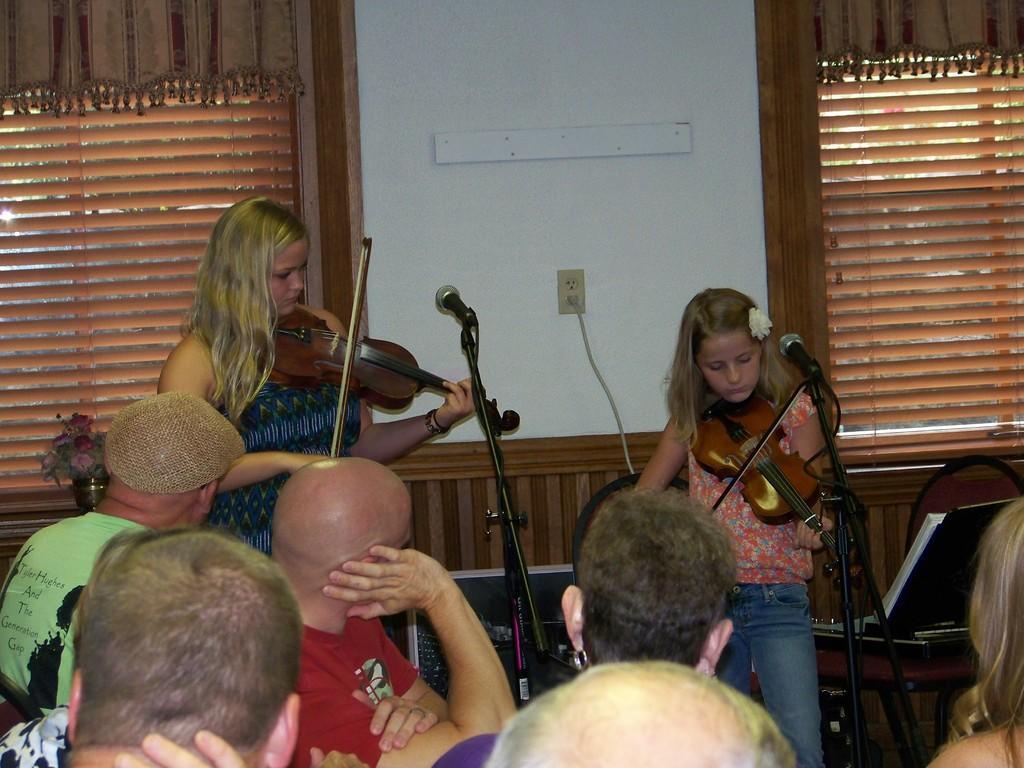Could you give a brief overview of what you see in this image? These two girls are playing violin in-front of mic. This is window with curtain. These are audience. A flower vase. On a table there is a box. 